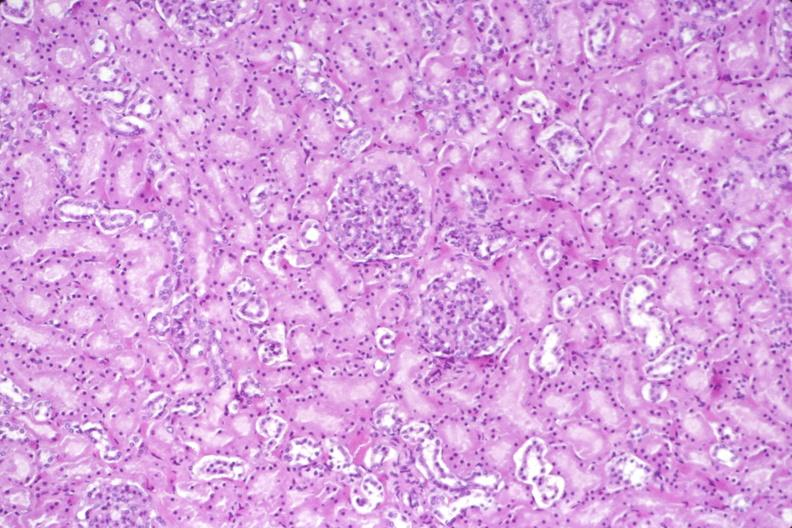does view of knee at autopsy show kidney, normal histology?
Answer the question using a single word or phrase. No 